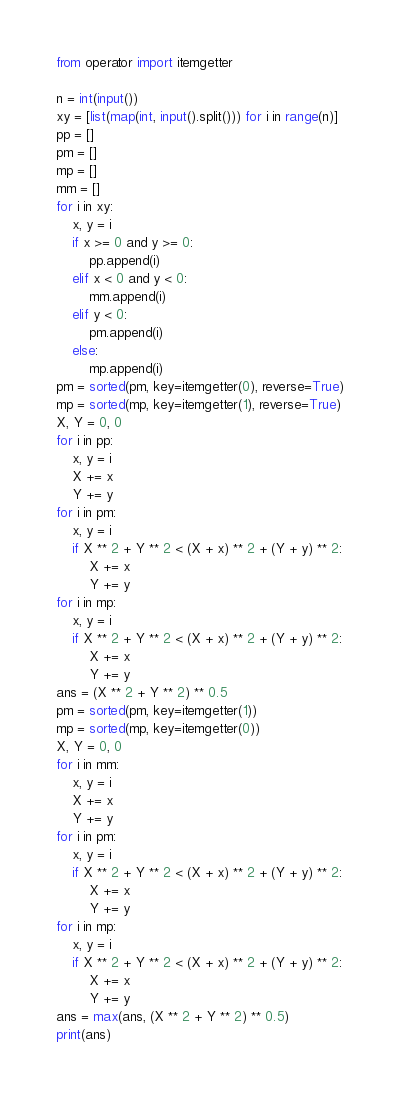<code> <loc_0><loc_0><loc_500><loc_500><_Python_>from operator import itemgetter

n = int(input())
xy = [list(map(int, input().split())) for i in range(n)]
pp = []
pm = []
mp = []
mm = []
for i in xy:
    x, y = i
    if x >= 0 and y >= 0:
        pp.append(i)
    elif x < 0 and y < 0:
        mm.append(i)
    elif y < 0:
        pm.append(i)
    else:
        mp.append(i)
pm = sorted(pm, key=itemgetter(0), reverse=True)
mp = sorted(mp, key=itemgetter(1), reverse=True)
X, Y = 0, 0
for i in pp:
    x, y = i
    X += x
    Y += y
for i in pm:
    x, y = i
    if X ** 2 + Y ** 2 < (X + x) ** 2 + (Y + y) ** 2:
        X += x
        Y += y
for i in mp:
    x, y = i
    if X ** 2 + Y ** 2 < (X + x) ** 2 + (Y + y) ** 2:
        X += x
        Y += y
ans = (X ** 2 + Y ** 2) ** 0.5
pm = sorted(pm, key=itemgetter(1))
mp = sorted(mp, key=itemgetter(0))
X, Y = 0, 0
for i in mm:
    x, y = i
    X += x
    Y += y
for i in pm:
    x, y = i
    if X ** 2 + Y ** 2 < (X + x) ** 2 + (Y + y) ** 2:
        X += x
        Y += y
for i in mp:
    x, y = i
    if X ** 2 + Y ** 2 < (X + x) ** 2 + (Y + y) ** 2:
        X += x
        Y += y
ans = max(ans, (X ** 2 + Y ** 2) ** 0.5)
print(ans)
</code> 